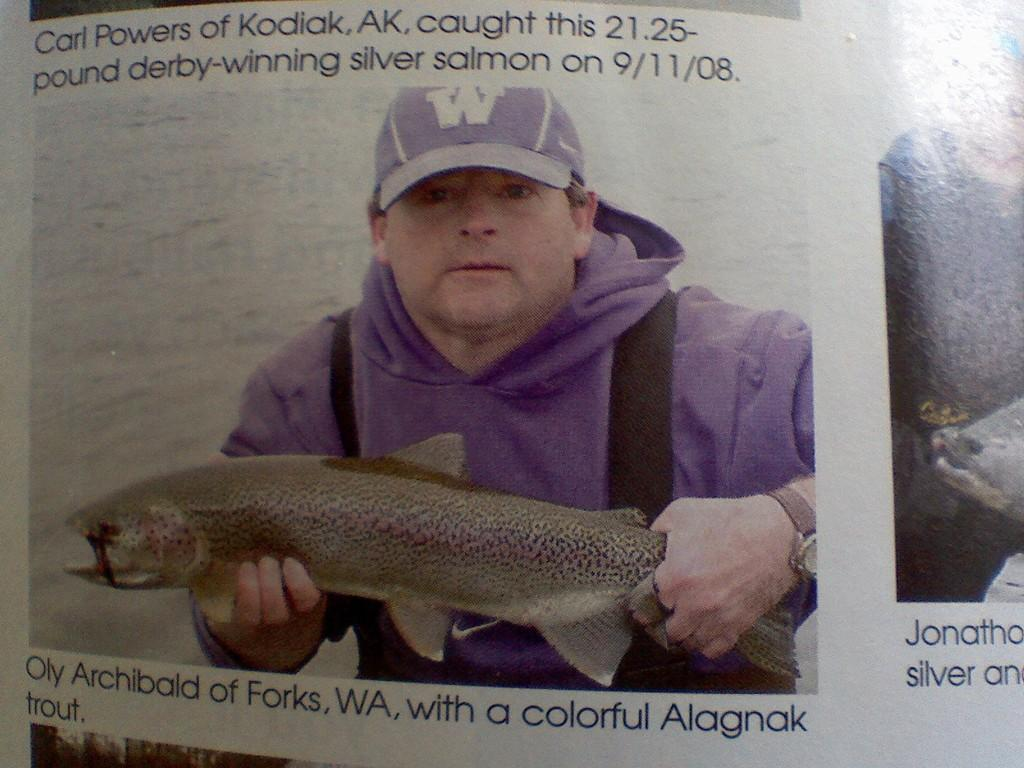Who is present in the image? There is a man in the image. What is the man holding in the image? The man is holding a fish. What type of reaction can be seen on the fish's face in the image? There is no face on the fish, as it is a real fish and not an anthropomorphic character. 